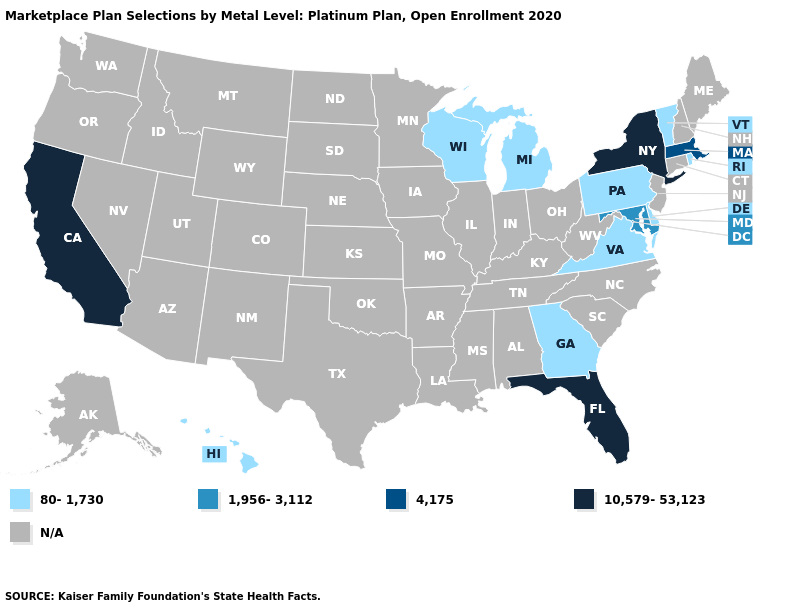What is the value of Vermont?
Keep it brief. 80-1,730. Does the map have missing data?
Short answer required. Yes. Name the states that have a value in the range 10,579-53,123?
Give a very brief answer. California, Florida, New York. Does the map have missing data?
Keep it brief. Yes. What is the lowest value in the USA?
Keep it brief. 80-1,730. Name the states that have a value in the range 4,175?
Write a very short answer. Massachusetts. What is the value of Arizona?
Give a very brief answer. N/A. Name the states that have a value in the range 10,579-53,123?
Quick response, please. California, Florida, New York. What is the highest value in states that border Kentucky?
Quick response, please. 80-1,730. What is the value of New Hampshire?
Quick response, please. N/A. Does Florida have the highest value in the South?
Keep it brief. Yes. What is the value of Georgia?
Quick response, please. 80-1,730. Does the map have missing data?
Short answer required. Yes. Which states hav the highest value in the West?
Be succinct. California. Which states have the lowest value in the USA?
Quick response, please. Delaware, Georgia, Hawaii, Michigan, Pennsylvania, Rhode Island, Vermont, Virginia, Wisconsin. 